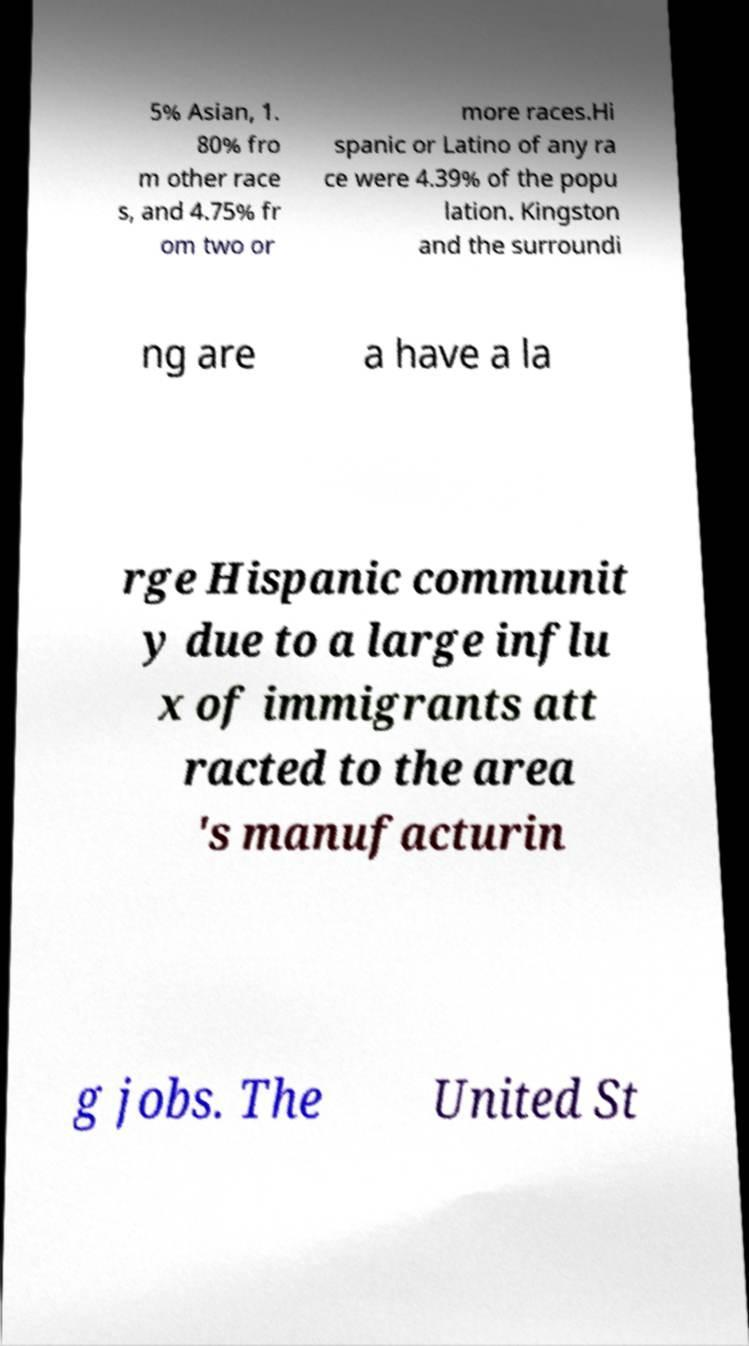Please read and relay the text visible in this image. What does it say? 5% Asian, 1. 80% fro m other race s, and 4.75% fr om two or more races.Hi spanic or Latino of any ra ce were 4.39% of the popu lation. Kingston and the surroundi ng are a have a la rge Hispanic communit y due to a large influ x of immigrants att racted to the area 's manufacturin g jobs. The United St 